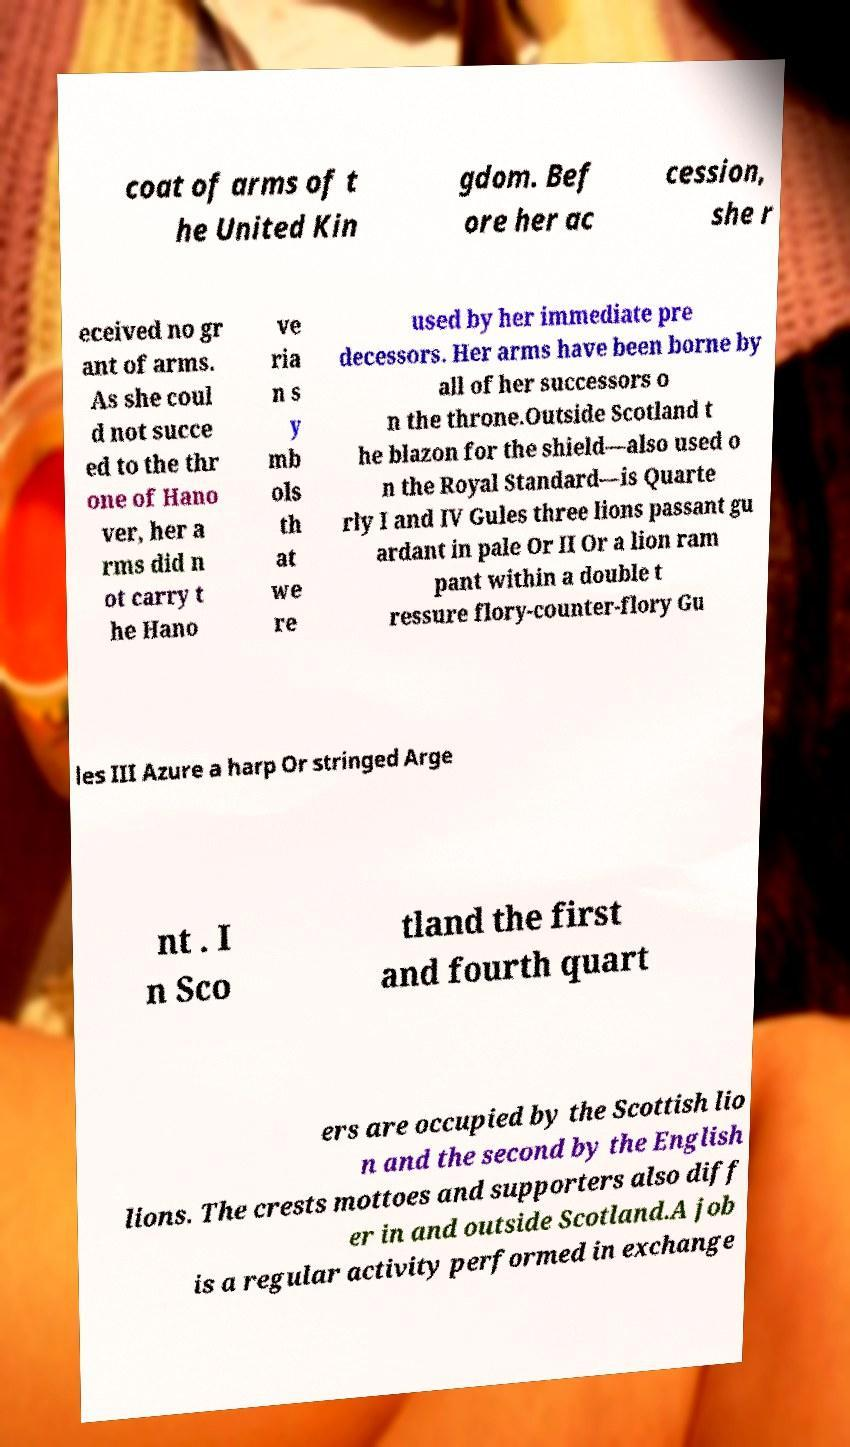For documentation purposes, I need the text within this image transcribed. Could you provide that? coat of arms of t he United Kin gdom. Bef ore her ac cession, she r eceived no gr ant of arms. As she coul d not succe ed to the thr one of Hano ver, her a rms did n ot carry t he Hano ve ria n s y mb ols th at we re used by her immediate pre decessors. Her arms have been borne by all of her successors o n the throne.Outside Scotland t he blazon for the shield—also used o n the Royal Standard—is Quarte rly I and IV Gules three lions passant gu ardant in pale Or II Or a lion ram pant within a double t ressure flory-counter-flory Gu les III Azure a harp Or stringed Arge nt . I n Sco tland the first and fourth quart ers are occupied by the Scottish lio n and the second by the English lions. The crests mottoes and supporters also diff er in and outside Scotland.A job is a regular activity performed in exchange 